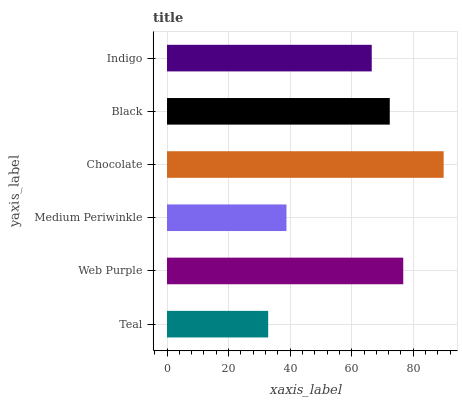Is Teal the minimum?
Answer yes or no. Yes. Is Chocolate the maximum?
Answer yes or no. Yes. Is Web Purple the minimum?
Answer yes or no. No. Is Web Purple the maximum?
Answer yes or no. No. Is Web Purple greater than Teal?
Answer yes or no. Yes. Is Teal less than Web Purple?
Answer yes or no. Yes. Is Teal greater than Web Purple?
Answer yes or no. No. Is Web Purple less than Teal?
Answer yes or no. No. Is Black the high median?
Answer yes or no. Yes. Is Indigo the low median?
Answer yes or no. Yes. Is Web Purple the high median?
Answer yes or no. No. Is Black the low median?
Answer yes or no. No. 